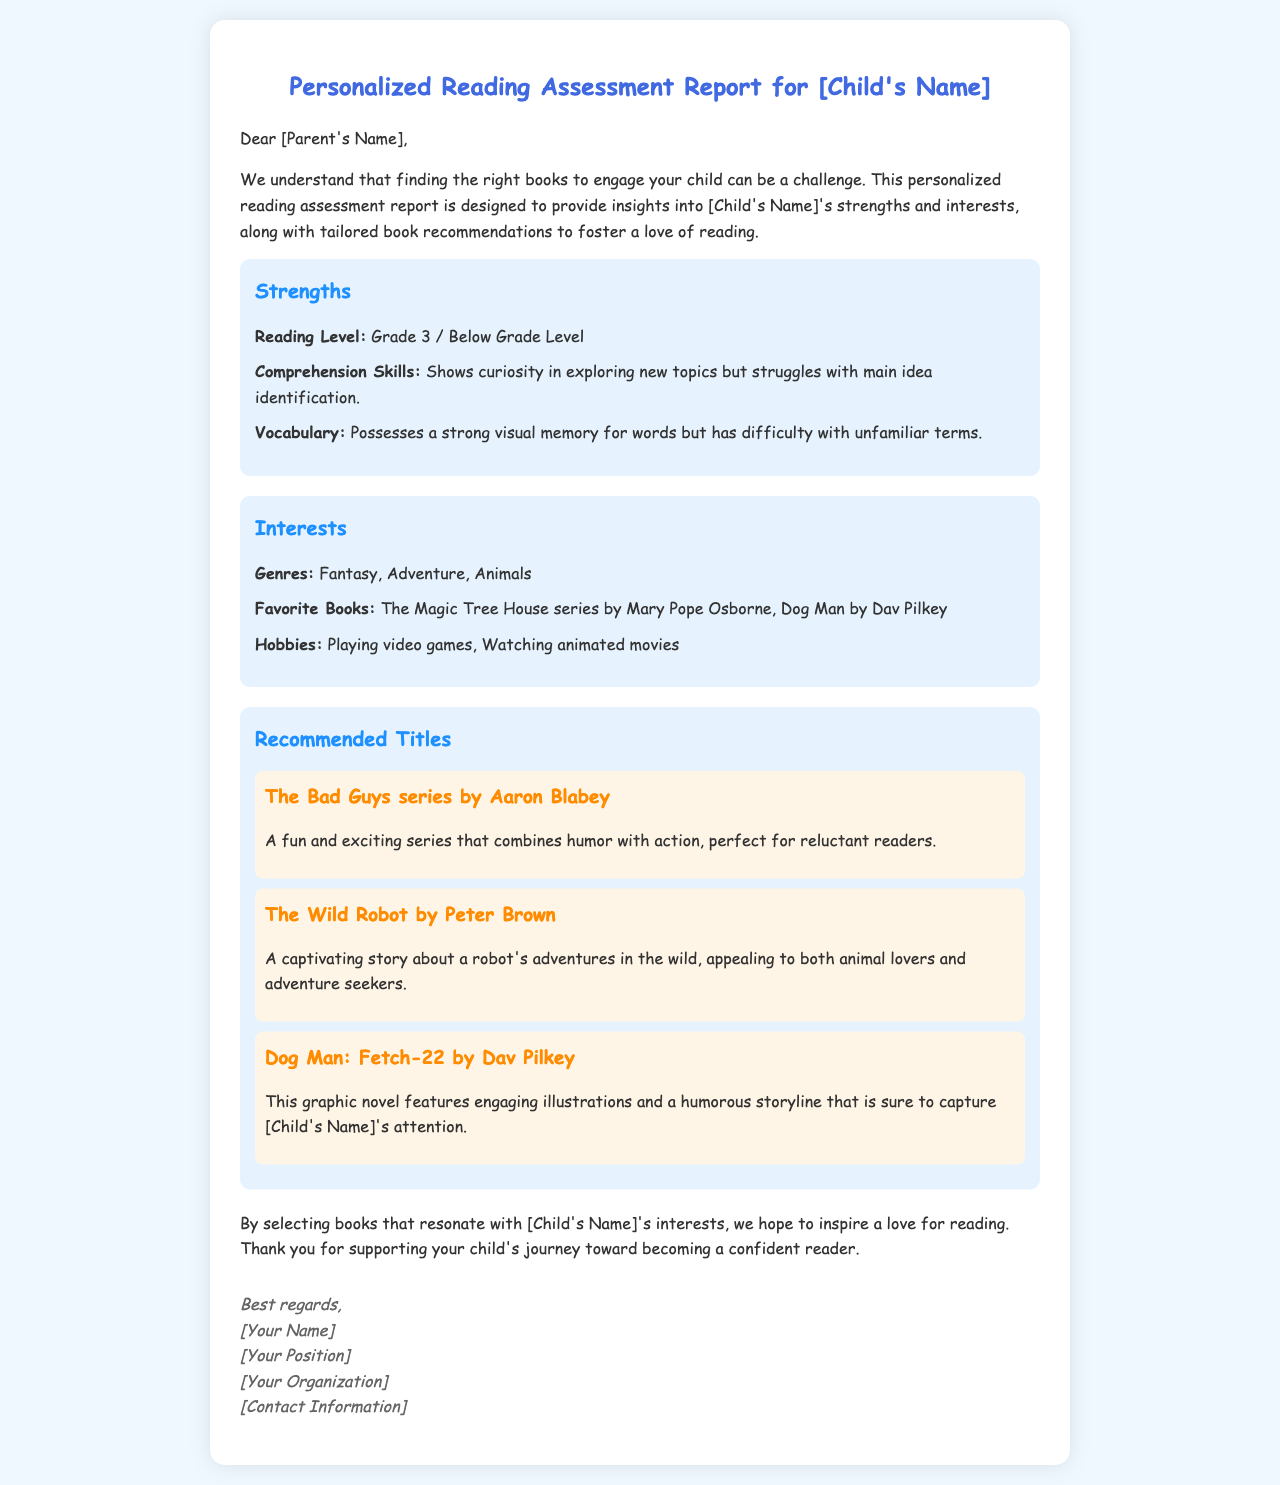What is [Child's Name]'s reading level? The reading level mentioned in the document is "Grade 3 / Below Grade Level."
Answer: Grade 3 / Below Grade Level What genres does [Child's Name] enjoy? The document lists their preferred genres as "Fantasy, Adventure, Animals."
Answer: Fantasy, Adventure, Animals What is one of [Child's Name]'s favorite books? The document provides several examples, one being "The Magic Tree House series by Mary Pope Osborne."
Answer: The Magic Tree House series What skill does [Child's Name] struggle with? The document states that [Child's Name] struggles with "main idea identification."
Answer: main idea identification Which title is recommended for reluctant readers? The document suggests "The Bad Guys series by Aaron Blabey," which is described as fun and exciting.
Answer: The Bad Guys series by Aaron Blabey Who is the author of "The Wild Robot"? The author mentioned in the document is "Peter Brown."
Answer: Peter Brown How does the report aim to support [Child's Name]? The report aims to inspire a love for reading by selecting books that resonate with [Child's Name]'s interests.
Answer: Inspire a love for reading What is the main purpose of the document? The main purpose is to provide insights into [Child's Name]'s strengths and interests along with tailored book recommendations.
Answer: Provide insights and recommendations 